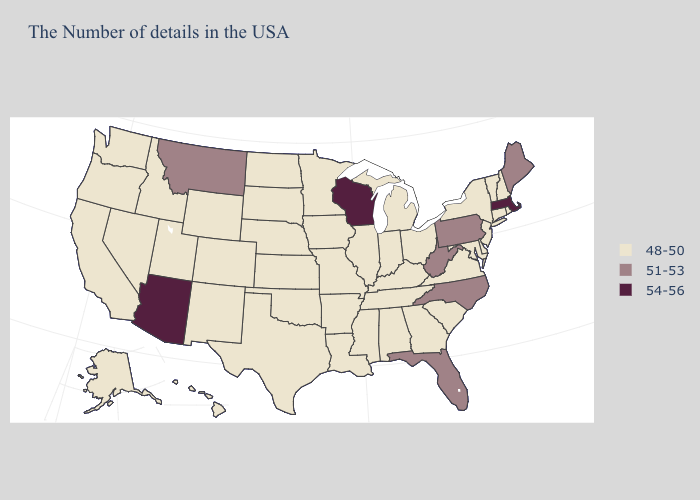Name the states that have a value in the range 48-50?
Write a very short answer. Rhode Island, New Hampshire, Vermont, Connecticut, New York, New Jersey, Delaware, Maryland, Virginia, South Carolina, Ohio, Georgia, Michigan, Kentucky, Indiana, Alabama, Tennessee, Illinois, Mississippi, Louisiana, Missouri, Arkansas, Minnesota, Iowa, Kansas, Nebraska, Oklahoma, Texas, South Dakota, North Dakota, Wyoming, Colorado, New Mexico, Utah, Idaho, Nevada, California, Washington, Oregon, Alaska, Hawaii. What is the lowest value in states that border Oklahoma?
Short answer required. 48-50. Among the states that border California , which have the highest value?
Give a very brief answer. Arizona. What is the highest value in states that border Arkansas?
Keep it brief. 48-50. Which states have the lowest value in the USA?
Concise answer only. Rhode Island, New Hampshire, Vermont, Connecticut, New York, New Jersey, Delaware, Maryland, Virginia, South Carolina, Ohio, Georgia, Michigan, Kentucky, Indiana, Alabama, Tennessee, Illinois, Mississippi, Louisiana, Missouri, Arkansas, Minnesota, Iowa, Kansas, Nebraska, Oklahoma, Texas, South Dakota, North Dakota, Wyoming, Colorado, New Mexico, Utah, Idaho, Nevada, California, Washington, Oregon, Alaska, Hawaii. Does Arizona have the lowest value in the West?
Write a very short answer. No. Name the states that have a value in the range 54-56?
Short answer required. Massachusetts, Wisconsin, Arizona. Does the map have missing data?
Give a very brief answer. No. What is the value of Mississippi?
Write a very short answer. 48-50. What is the highest value in states that border New York?
Give a very brief answer. 54-56. Is the legend a continuous bar?
Short answer required. No. What is the value of Maryland?
Quick response, please. 48-50. What is the lowest value in the MidWest?
Keep it brief. 48-50. Which states have the highest value in the USA?
Give a very brief answer. Massachusetts, Wisconsin, Arizona. What is the value of Alabama?
Write a very short answer. 48-50. 